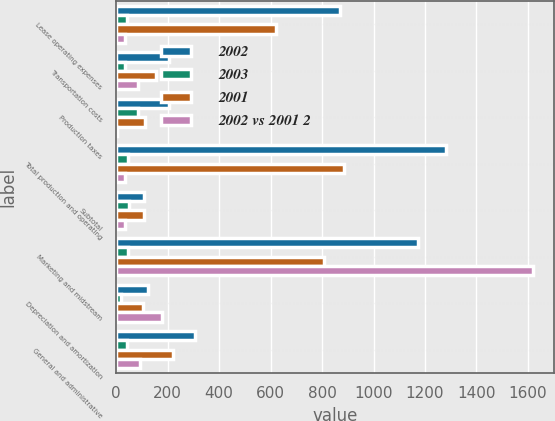Convert chart to OTSL. <chart><loc_0><loc_0><loc_500><loc_500><stacked_bar_chart><ecel><fcel>Lease operating expenses<fcel>Transportation costs<fcel>Production taxes<fcel>Total production and operating<fcel>Subtotal<fcel>Marketing and midstream<fcel>Depreciation and amortization<fcel>General and administrative<nl><fcel>2002<fcel>871<fcel>207<fcel>204<fcel>1282<fcel>108<fcel>1174<fcel>125<fcel>307<nl><fcel>2003<fcel>40<fcel>34<fcel>84<fcel>45<fcel>50<fcel>45<fcel>19<fcel>40<nl><fcel>2001<fcel>621<fcel>154<fcel>111<fcel>886<fcel>108<fcel>808<fcel>105<fcel>219<nl><fcel>2002 vs 2001 2<fcel>33<fcel>86<fcel>4<fcel>33<fcel>33<fcel>1619<fcel>176<fcel>92<nl></chart> 